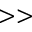Convert formula to latex. <formula><loc_0><loc_0><loc_500><loc_500>> ></formula> 